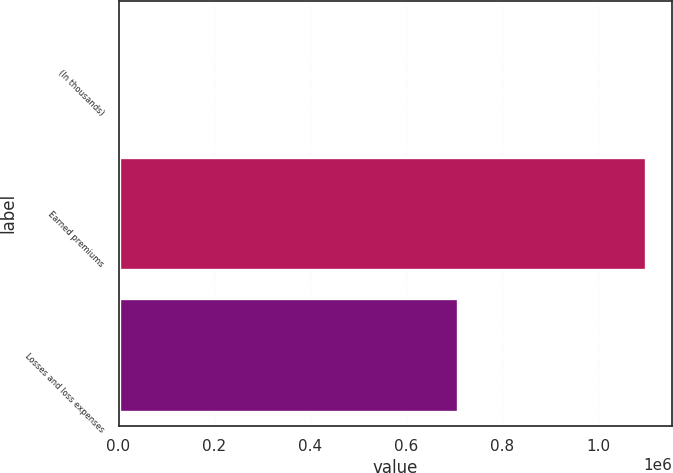<chart> <loc_0><loc_0><loc_500><loc_500><bar_chart><fcel>(In thousands)<fcel>Earned premiums<fcel>Losses and loss expenses<nl><fcel>2016<fcel>1.09946e+06<fcel>707336<nl></chart> 